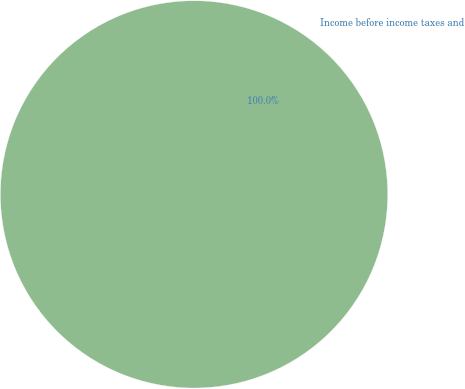Convert chart. <chart><loc_0><loc_0><loc_500><loc_500><pie_chart><fcel>Income before income taxes and<nl><fcel>100.0%<nl></chart> 